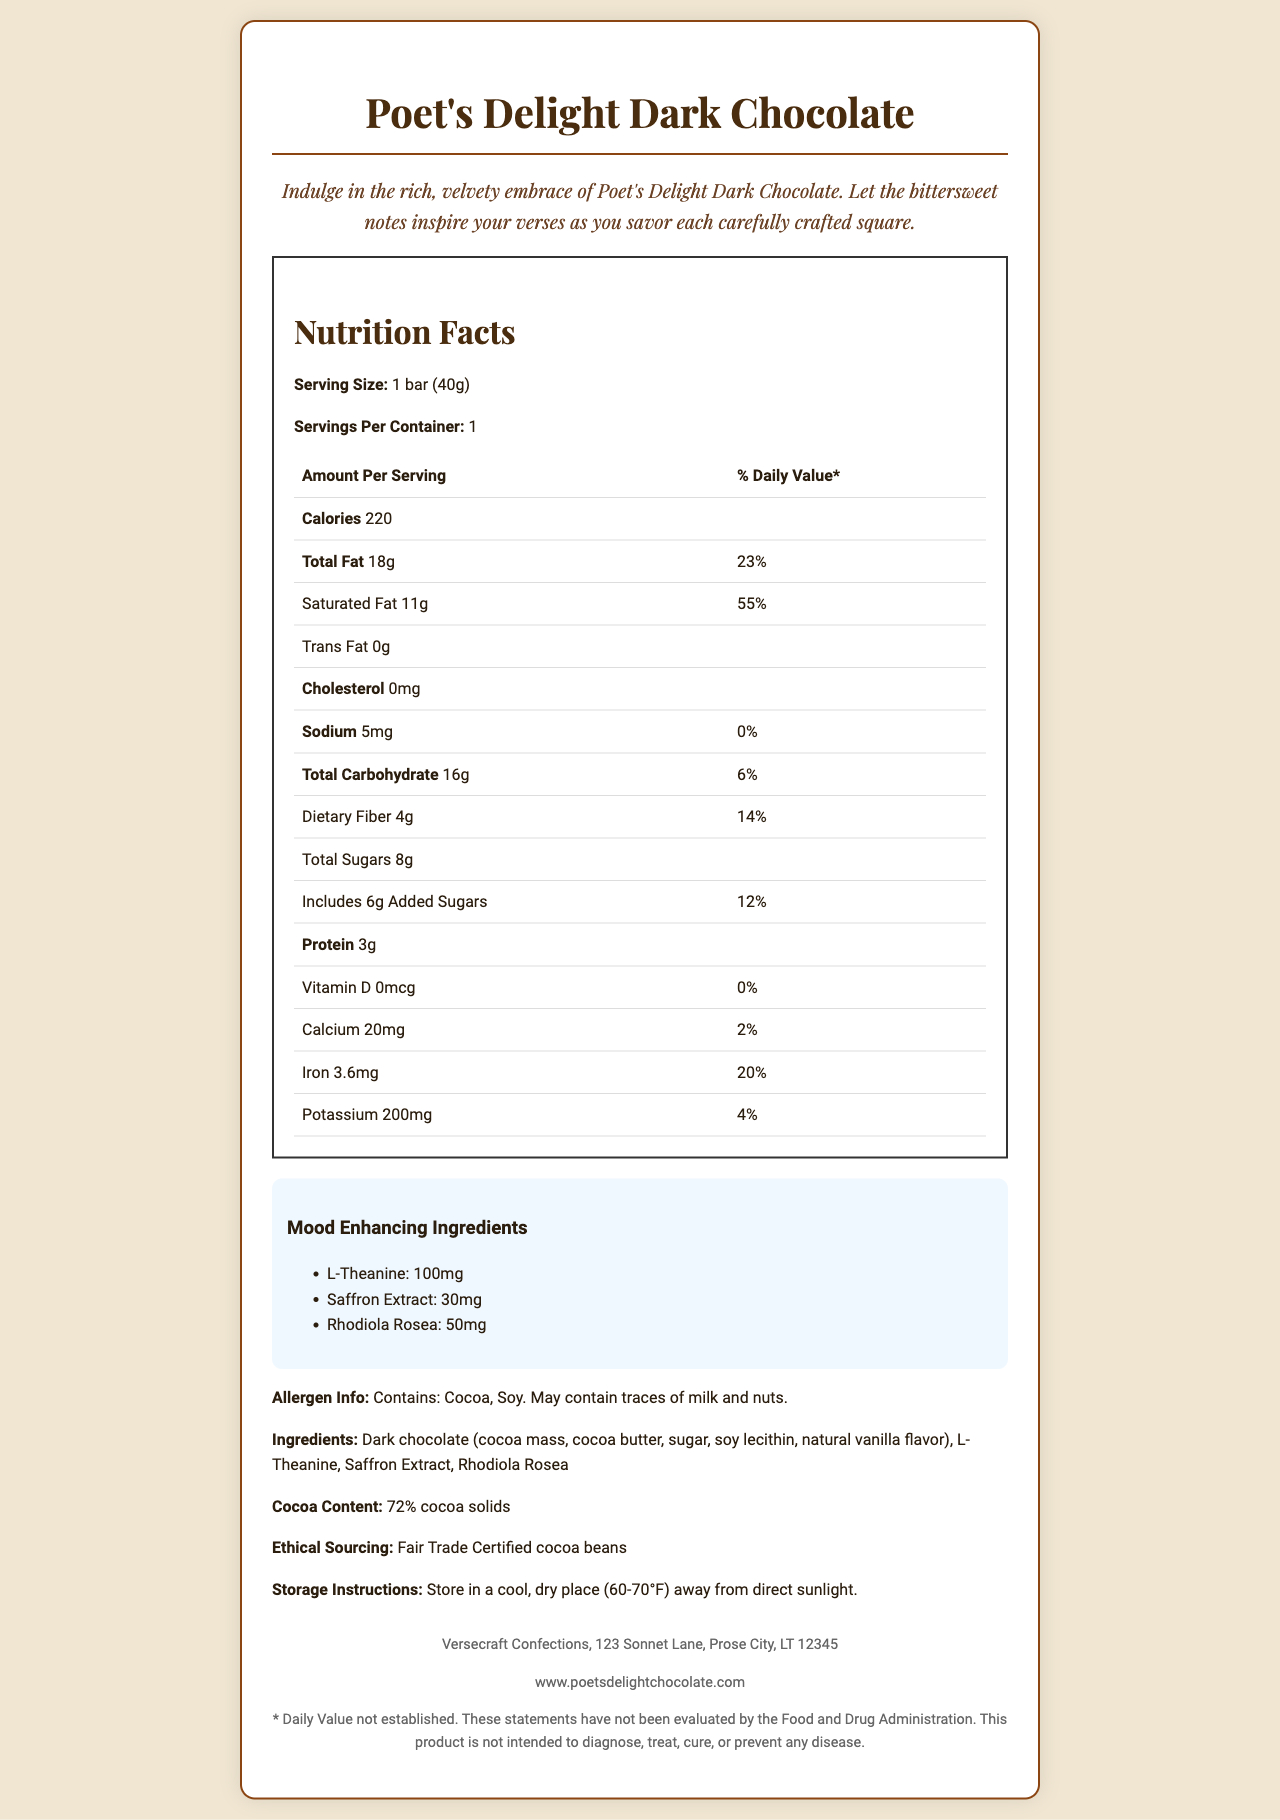who is the manufacturer of the Poet's Delight Dark Chocolate? The manufacturer is listed in the footer section of the document as Versecraft Confections, 123 Sonnet Lane, Prose City, LT 12345.
Answer: Versecraft Confections what is the total calorie content per serving? The calorie content is explicitly stated under the "Calories" section in the Nutrition Facts table.
Answer: 220 calories how much dietary fiber does one serving contain? The dietary fiber content is found in the Nutrition Facts, where it states that each serving contains 4g of dietary fiber.
Answer: 4g what percentage of the daily value of iron is provided per serving? The Nutrition Facts table shows that one serving provides 20% of the daily value of iron.
Answer: 20% list all mood-enhancing ingredients included in the chocolate bar. These ingredients are specified in the "Mood Enhancing Ingredients" section of the document.
Answer: L-Theanine, Saffron Extract, Rhodiola Rosea what is the serving size for the Poet's Delight Dark Chocolate? A. 30g B. 40g C. 50g D. 60g The serving size is listed at the top of the Nutrition Facts as "1 bar (40g)".
Answer: B. 40g which of the following is NOT an ingredient in Poet's Delight Dark Chocolate? A. Cocoa butter B. Rhodiola Rosea C. Almonds D. Soy lecithin The ingredient list includes cocoa butter, Rhodiola Rosea, and soy lecithin, but not almonds.
Answer: C. Almonds does the Poet's Delight Dark Chocolate contain trans fat? The Nutrition Facts explicitly states that there is 0g of trans fat per serving.
Answer: No describe the packaging inspiration for Poet's Delight Dark Chocolate. The document states that the chocolate is wrapped in parchment paper with literary quotes from Emily Dickinson.
Answer: The packaging is inspired by literary works and is wrapped in parchment paper with quotes from Emily Dickinson's "Hope is the Thing with Feathers". what is the price of the Poet's Delight Dark Chocolate? The document does not provide any information regarding the price of the chocolate.
Answer: Cannot be determined does the Poet's Delight Dark Chocolate contain any allergens, and if so, what are they? The allergen information section mentions that the product contains cocoa and soy and may contain traces of milk and nuts.
Answer: Yes, it contains cocoa and soy, and may contain traces of milk and nuts. summarize the main idea of the Poet's Delight Dark Chocolate document. The document primarily provides detailed information about the nutrition, mood-enhancing ingredients, allergen warnings, and product features like ethical sourcing and packaging design.
Answer: The document describes the nutrition facts, ingredients, and unique features of the Poet's Delight Dark Chocolate. It highlights the mood-enhancing components, the ethical sourcing of its cocoa, and its literary-inspired packaging. 